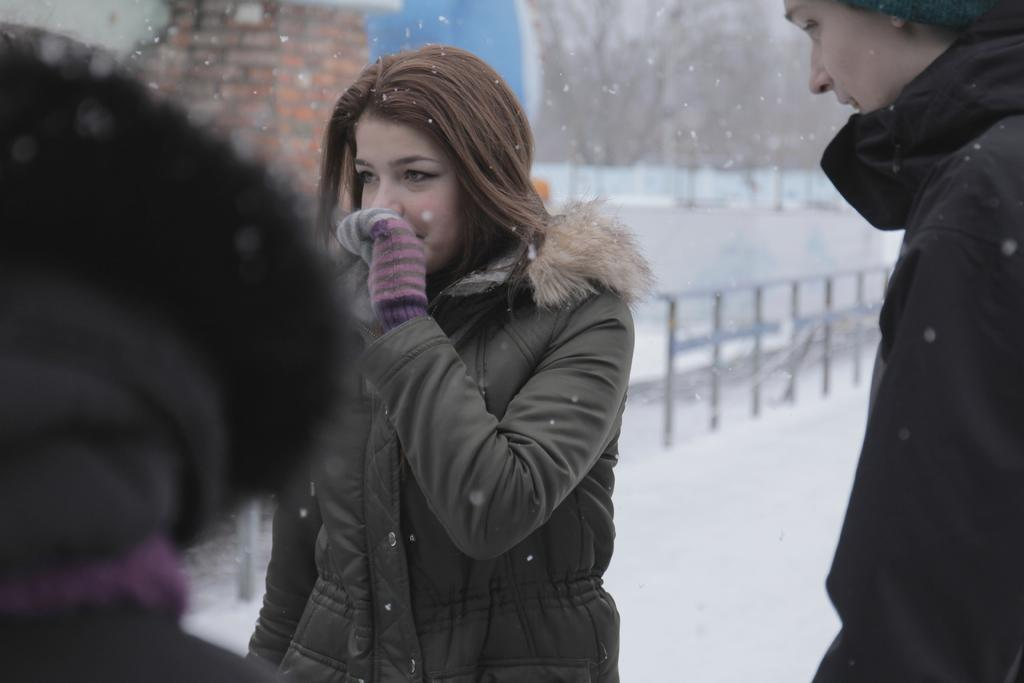Who or what can be seen in the image? There are people in the image. What is the background of the image like? There is snow and a rail in the background of the image. What type of magic is being performed by the actor in the image? There is no actor or magic present in the image; it features people in a snowy background with a rail. 